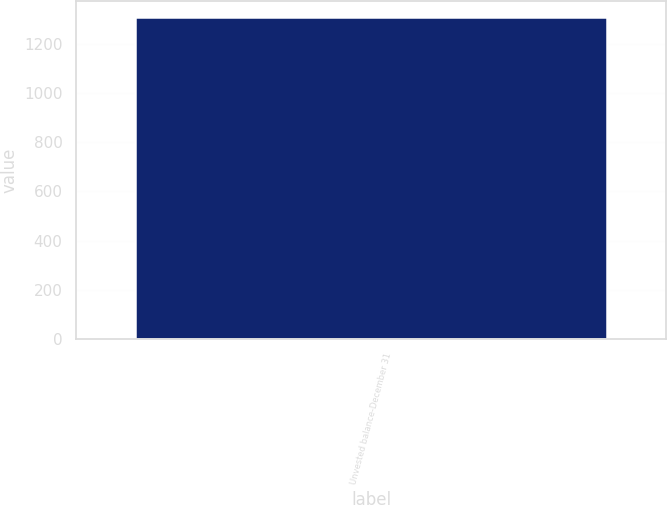<chart> <loc_0><loc_0><loc_500><loc_500><bar_chart><fcel>Unvested balance-December 31<nl><fcel>1308<nl></chart> 